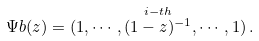Convert formula to latex. <formula><loc_0><loc_0><loc_500><loc_500>\Psi b ( z ) = ( 1 , \cdots , \overset { i - t h } { ( 1 - z ) ^ { - 1 } } , \cdots , 1 ) \, .</formula> 